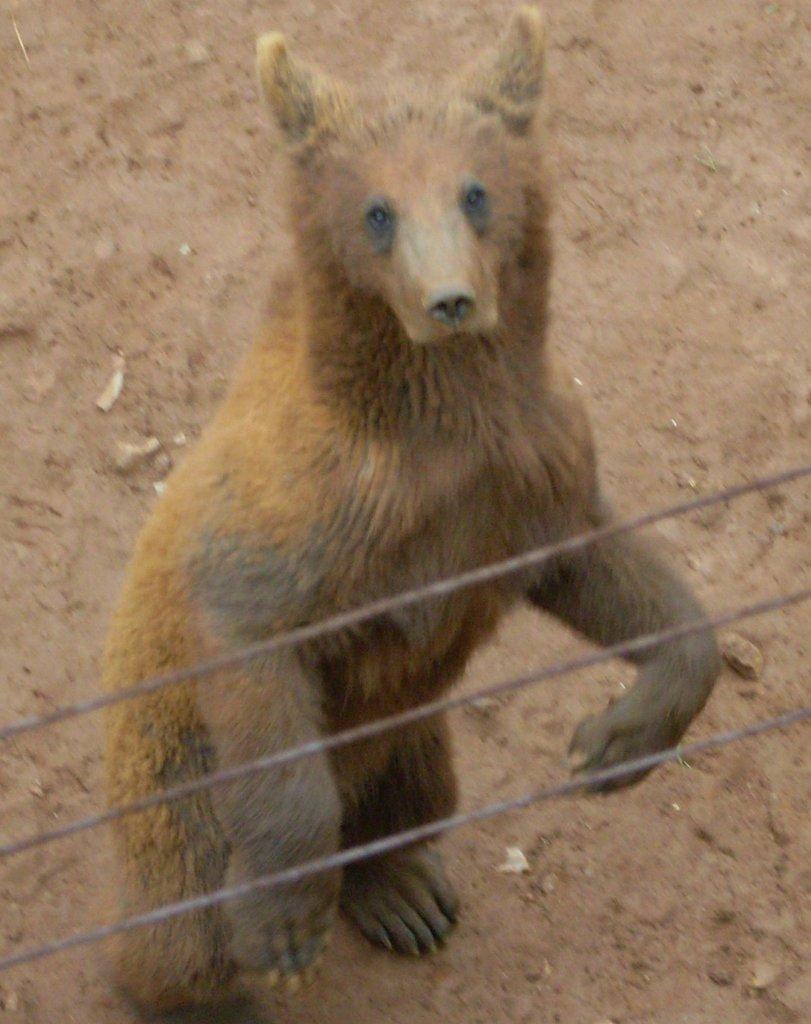Could you give a brief overview of what you see in this image? In this image we can see an animal and also three wires. In the background we can see the ground. 